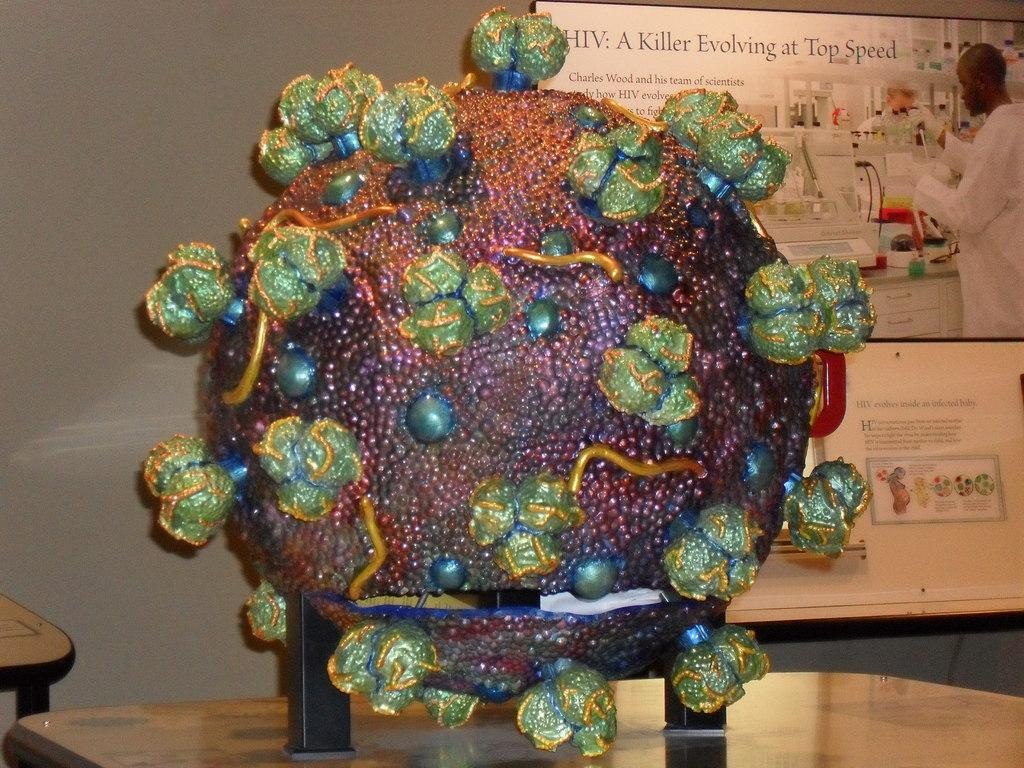What type of furniture is present in the image? There is a table in the image. What is placed on the table? There is a craft on the table. What colors are used in the craft? The craft is in green and other colors. What can be seen on the wall behind the table? There is a poster on the wall behind the table. What type of pan is being used to cook the son in the image? There is no pan or son present in the image; it only features a table with a craft and a poster on the wall. 